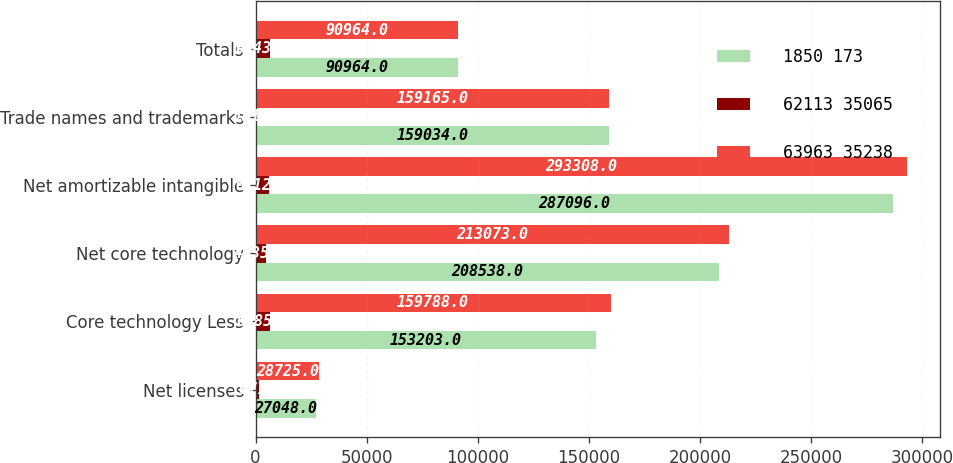Convert chart. <chart><loc_0><loc_0><loc_500><loc_500><stacked_bar_chart><ecel><fcel>Net licenses<fcel>Core technology Less<fcel>Net core technology<fcel>Net amortizable intangible<fcel>Trade names and trademarks<fcel>Totals<nl><fcel>1850 173<fcel>27048<fcel>153203<fcel>208538<fcel>287096<fcel>159034<fcel>90964<nl><fcel>62113 35065<fcel>1677<fcel>6585<fcel>4535<fcel>6212<fcel>131<fcel>6343<nl><fcel>63963 35238<fcel>28725<fcel>159788<fcel>213073<fcel>293308<fcel>159165<fcel>90964<nl></chart> 